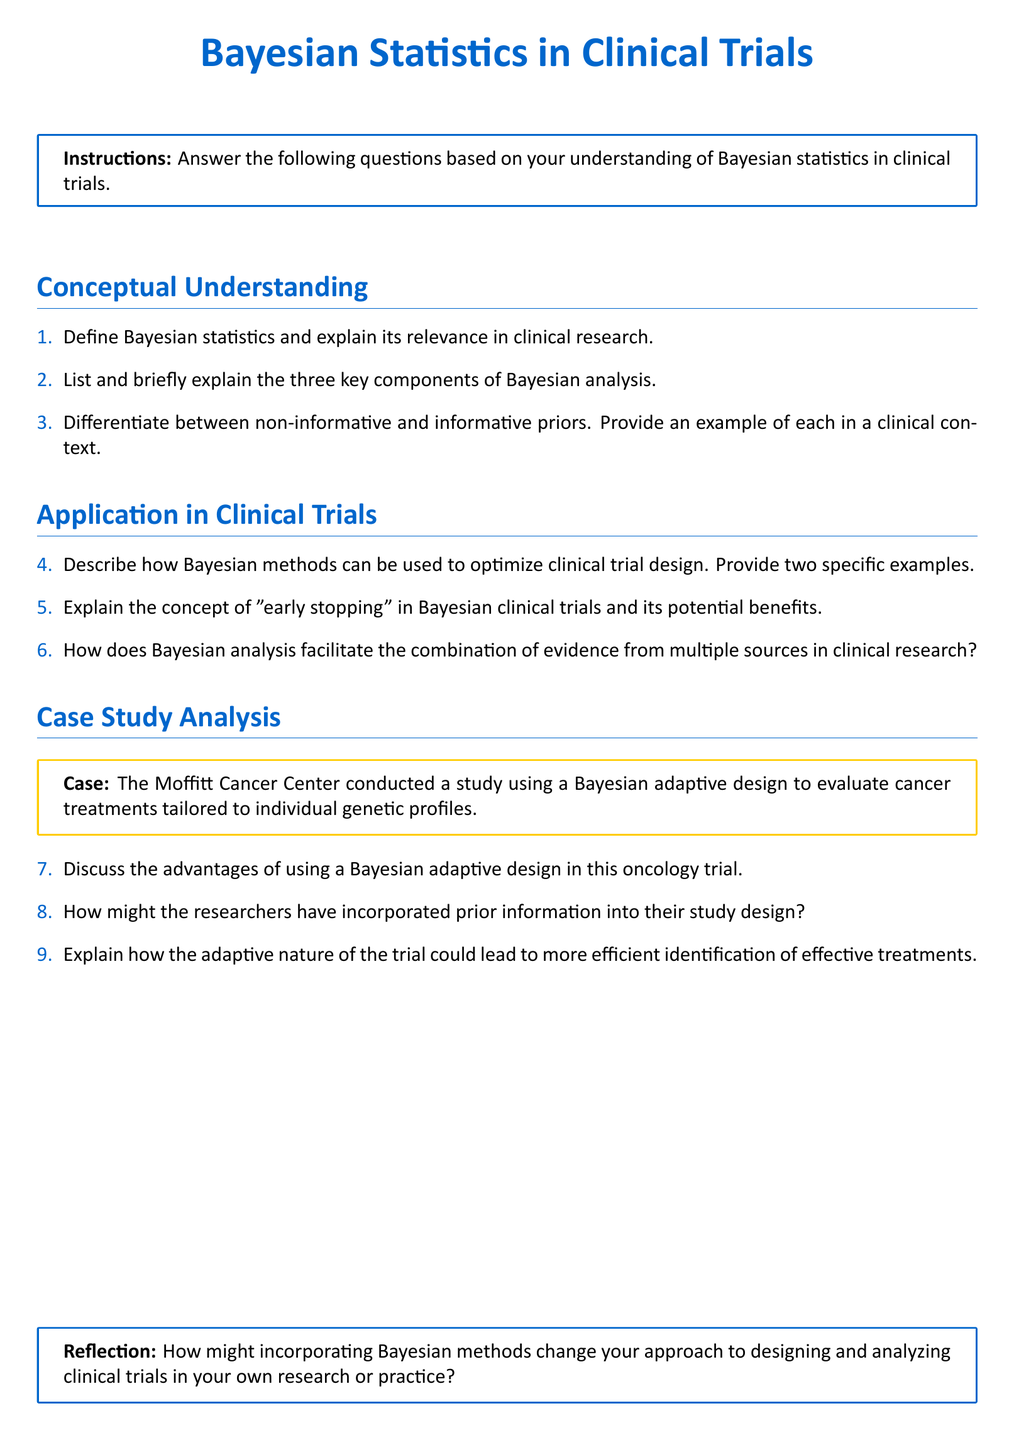What is the title of the document? The title is prominently displayed at the top of the document, summarizing the main focus on Bayesian statistics in clinical trials.
Answer: Bayesian Statistics in Clinical Trials How many key components of Bayesian analysis are listed? The document specifies that there are three key components of Bayesian analysis included in the questionnaire.
Answer: 3 What are the two types of priors mentioned? The document highlights non-informative and informative priors as two distinct categories in Bayesian statistics.
Answer: Non-informative and informative What potential benefit of Bayesian "early stopping" is suggested? The document implies that "early stopping" could provide benefits, though the specifics are to be derived from the reader's understanding.
Answer: Potential benefits Where is the case study from? The case study is about a specific organization noted for conducting a relevant clinical trial.
Answer: Moffitt Cancer Center How can Bayesian methods optimize trial design? The document asks for examples of this application, implying a need to identify specific strategies effectively.
Answer: Provide two specific examples What is the focus of the reflection section? The reflection section invites the reader to contemplate personal implications of the discussed methods in their clinical work.
Answer: Designing and analyzing clinical trials What color is used for the main headings in the document? The document utilizes a specific color to maintain uniformity and visual appeal in the overall structure.
Answer: Main color: RGB(0,102,204) What format should the answers adhere to in the document? The format instructions are explicitly provided, guiding how responses should align with the components listed.
Answer: Short-answer questions 